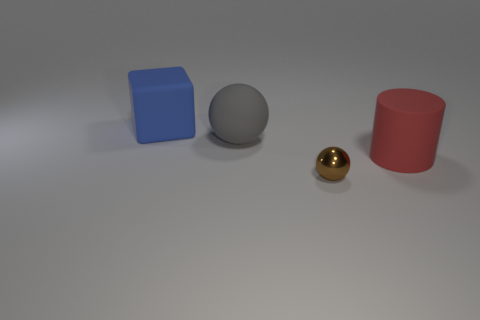What number of big gray matte spheres are there?
Ensure brevity in your answer.  1. What is the material of the ball behind the big rubber object in front of the gray sphere?
Provide a succinct answer. Rubber. The large cylinder that is made of the same material as the gray ball is what color?
Your answer should be very brief. Red. Is the size of the ball behind the brown ball the same as the thing in front of the red rubber cylinder?
Make the answer very short. No. How many cylinders are big blue objects or big gray matte things?
Your answer should be compact. 0. Do the cube that is behind the gray ball and the brown ball have the same material?
Offer a terse response. No. What number of other objects are there of the same size as the red cylinder?
Offer a terse response. 2. How many big things are cyan blocks or metallic things?
Provide a short and direct response. 0. Does the matte cylinder have the same color as the cube?
Keep it short and to the point. No. Are there more large blue matte things that are on the right side of the red thing than small brown shiny objects that are to the left of the gray rubber sphere?
Keep it short and to the point. No. 